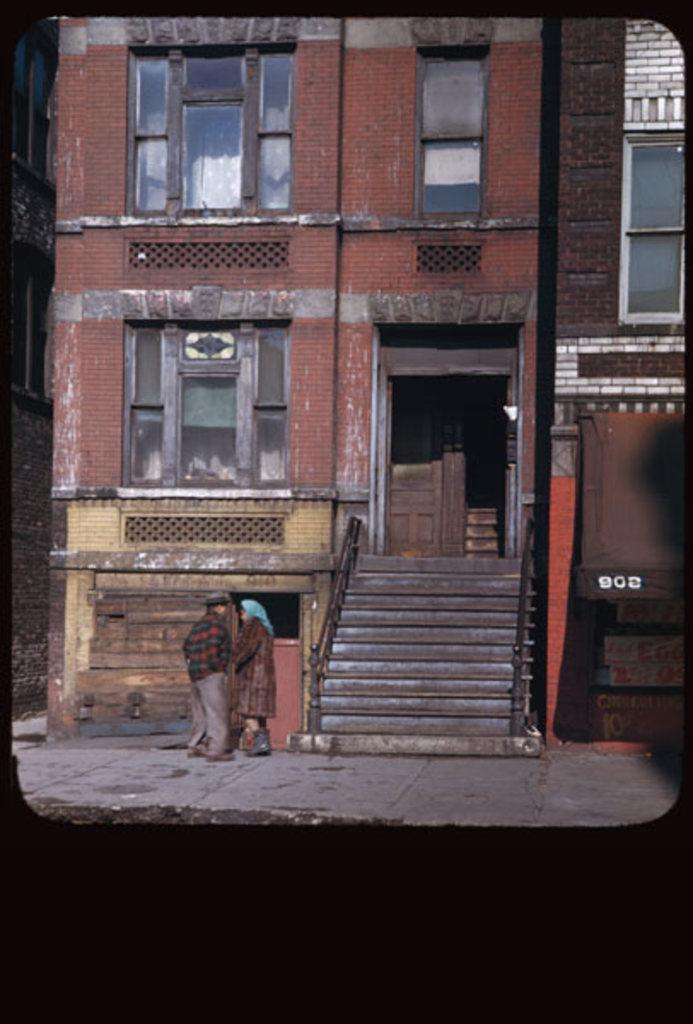What type of structure is visible in the image? There is a building in the image. What features can be observed on the building? The building has windows, stairs, and railings. Who is present in the image? There is a man and a woman standing in the image. What color is used for the borders of the image? The borders of the image are in black color. What type of wax is being used by the man in the image? There is no wax or any indication of wax use in the image. How many eyes does the woman have in the image? The image does not show the woman's eyes, so it is impossible to determine the number of eyes she has. 